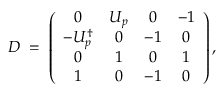<formula> <loc_0><loc_0><loc_500><loc_500>D \, = \, \left ( \begin{array} { c c c c } { 0 } & { { U _ { p } } } & { 0 } & { - 1 } \\ { { - U _ { p } ^ { \dagger } } } & { 0 } & { - 1 } & { 0 } \\ { 0 } & { 1 } & { 0 } & { 1 } \\ { 1 } & { 0 } & { - 1 } & { 0 } \end{array} \right ) ,</formula> 